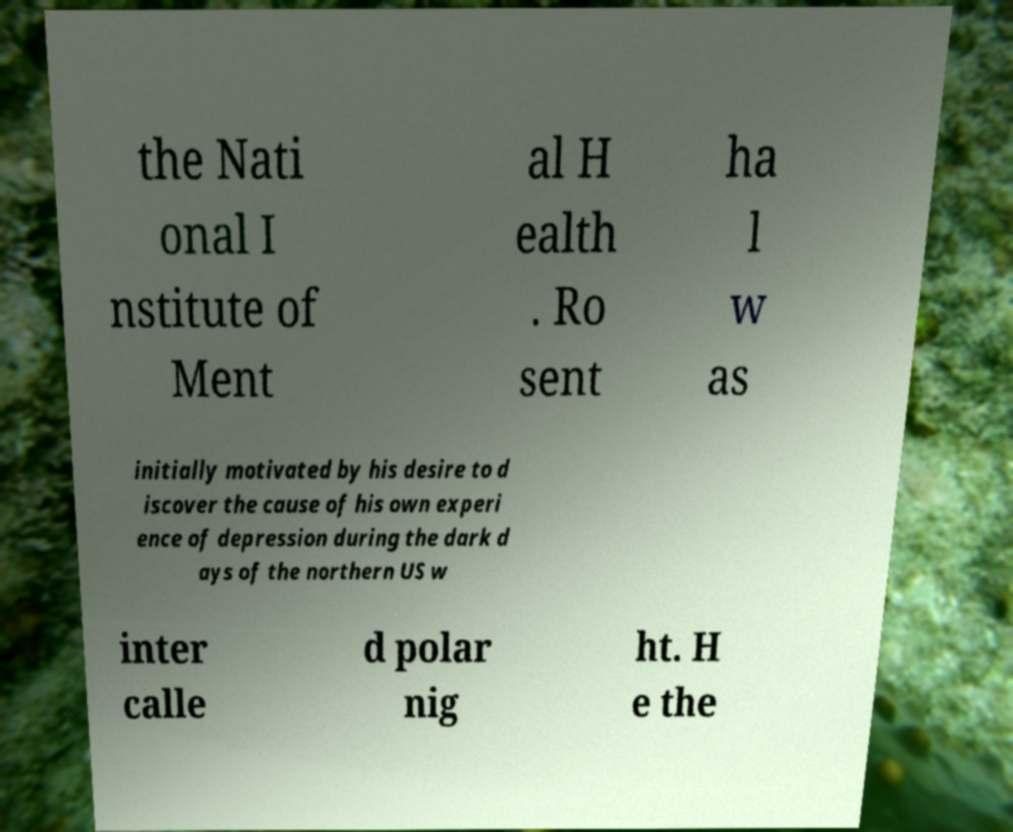Could you assist in decoding the text presented in this image and type it out clearly? the Nati onal I nstitute of Ment al H ealth . Ro sent ha l w as initially motivated by his desire to d iscover the cause of his own experi ence of depression during the dark d ays of the northern US w inter calle d polar nig ht. H e the 